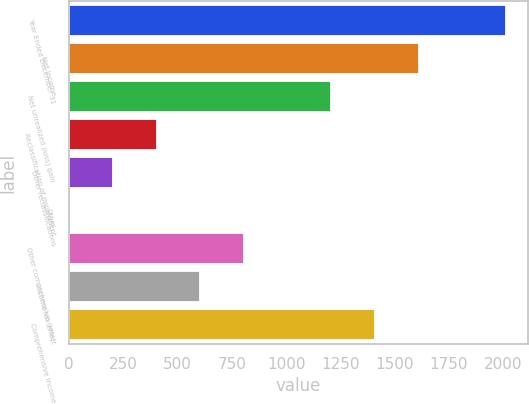Convert chart to OTSL. <chart><loc_0><loc_0><loc_500><loc_500><bar_chart><fcel>Year Ended December 31<fcel>Net income<fcel>Net unrealized (loss) gain<fcel>Reclassification of impairment<fcel>Other reclassifications<fcel>Other<fcel>Other comprehensive (loss)<fcel>Income tax effect<fcel>Comprehensive Income<nl><fcel>2013<fcel>1610.6<fcel>1208.2<fcel>403.4<fcel>202.2<fcel>1<fcel>805.8<fcel>604.6<fcel>1409.4<nl></chart> 